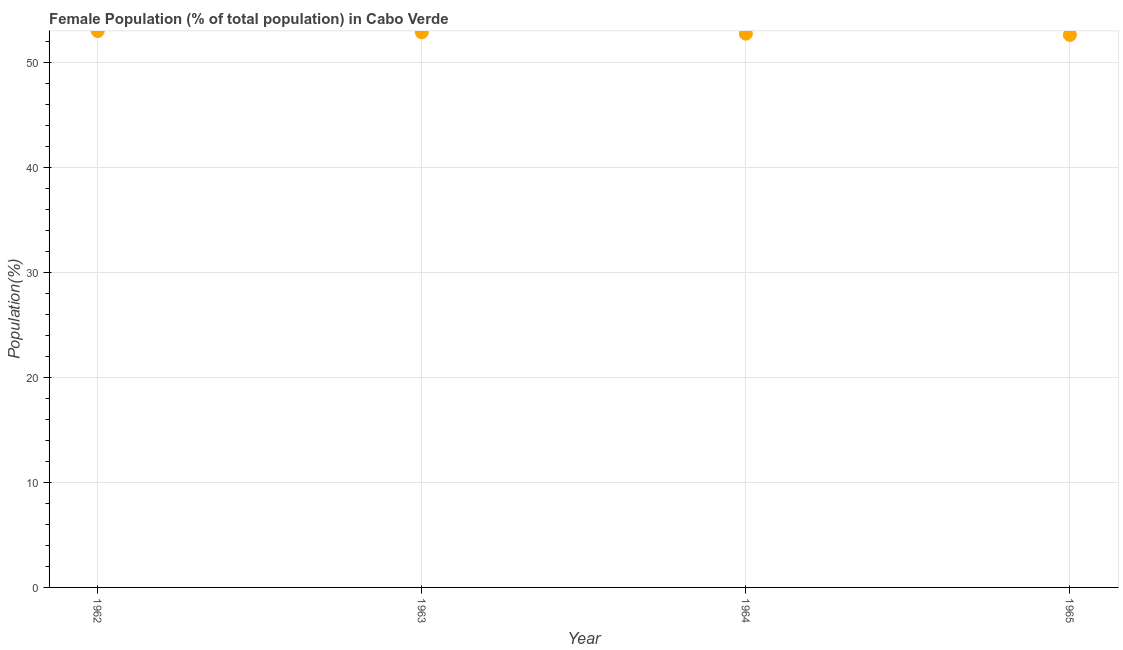What is the female population in 1965?
Provide a succinct answer. 52.6. Across all years, what is the maximum female population?
Provide a succinct answer. 52.97. Across all years, what is the minimum female population?
Offer a terse response. 52.6. In which year was the female population minimum?
Offer a terse response. 1965. What is the sum of the female population?
Provide a succinct answer. 211.15. What is the difference between the female population in 1963 and 1964?
Ensure brevity in your answer.  0.13. What is the average female population per year?
Keep it short and to the point. 52.79. What is the median female population?
Offer a terse response. 52.79. In how many years, is the female population greater than 28 %?
Ensure brevity in your answer.  4. Do a majority of the years between 1962 and 1965 (inclusive) have female population greater than 30 %?
Offer a terse response. Yes. What is the ratio of the female population in 1963 to that in 1964?
Keep it short and to the point. 1. Is the female population in 1962 less than that in 1963?
Give a very brief answer. No. What is the difference between the highest and the second highest female population?
Offer a terse response. 0.12. What is the difference between the highest and the lowest female population?
Make the answer very short. 0.37. In how many years, is the female population greater than the average female population taken over all years?
Your answer should be compact. 2. Does the female population monotonically increase over the years?
Offer a very short reply. No. How many dotlines are there?
Offer a terse response. 1. How many years are there in the graph?
Your response must be concise. 4. What is the difference between two consecutive major ticks on the Y-axis?
Offer a terse response. 10. Does the graph contain any zero values?
Your answer should be compact. No. Does the graph contain grids?
Your response must be concise. Yes. What is the title of the graph?
Give a very brief answer. Female Population (% of total population) in Cabo Verde. What is the label or title of the Y-axis?
Ensure brevity in your answer.  Population(%). What is the Population(%) in 1962?
Give a very brief answer. 52.97. What is the Population(%) in 1963?
Provide a succinct answer. 52.85. What is the Population(%) in 1964?
Make the answer very short. 52.72. What is the Population(%) in 1965?
Your answer should be compact. 52.6. What is the difference between the Population(%) in 1962 and 1963?
Provide a short and direct response. 0.12. What is the difference between the Population(%) in 1962 and 1964?
Your response must be concise. 0.26. What is the difference between the Population(%) in 1962 and 1965?
Make the answer very short. 0.37. What is the difference between the Population(%) in 1963 and 1964?
Your answer should be compact. 0.13. What is the difference between the Population(%) in 1963 and 1965?
Make the answer very short. 0.25. What is the difference between the Population(%) in 1964 and 1965?
Provide a short and direct response. 0.12. What is the ratio of the Population(%) in 1962 to that in 1964?
Offer a very short reply. 1. What is the ratio of the Population(%) in 1962 to that in 1965?
Keep it short and to the point. 1.01. What is the ratio of the Population(%) in 1963 to that in 1964?
Your response must be concise. 1. What is the ratio of the Population(%) in 1964 to that in 1965?
Your answer should be very brief. 1. 